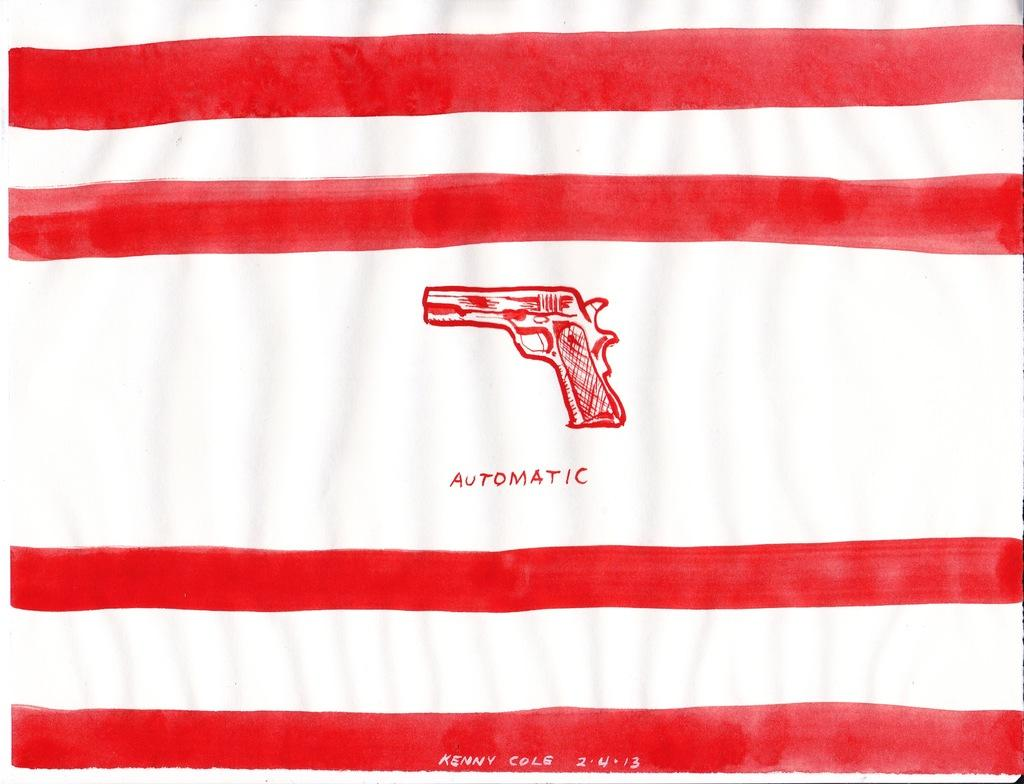What is the main object in the image? There is a white flag in the image. What colors are present on the flag? The flag has red lines on it. Are there any words or letters on the flag? Yes, there is text on the flag. What image is depicted on the flag? There is a painting of a gun on the flag. What type of dress can be seen hanging on the flagpole in the image? There is no dress present in the image; it only features a white flag with red lines, text, and a painting of a gun. Can you describe the clouds in the image? There are no clouds visible in the image; it only features a white flag. 